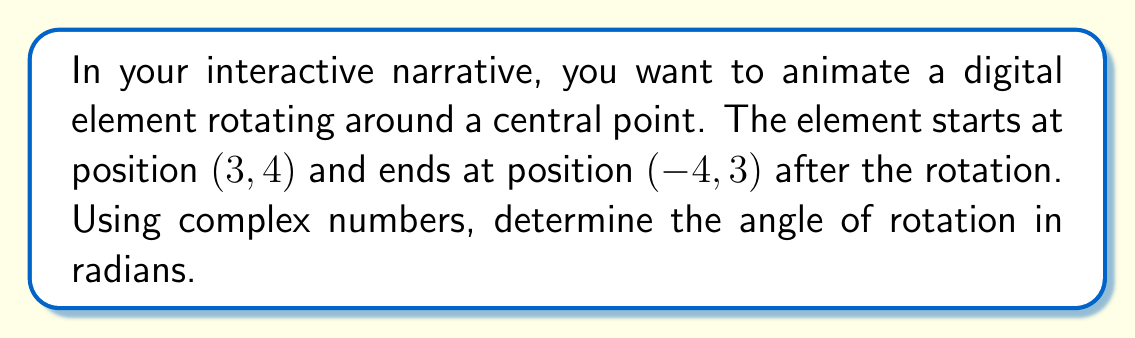Teach me how to tackle this problem. To solve this problem, we'll follow these steps:

1) Represent the initial and final positions as complex numbers:
   Initial: $z_1 = 3 + 4i$
   Final: $z_2 = -4 + 3i$

2) The rotation angle $\theta$ is the argument of the quotient $\frac{z_2}{z_1}$:

   $$\theta = \arg\left(\frac{z_2}{z_1}\right)$$

3) Calculate $\frac{z_2}{z_1}$:

   $$\frac{z_2}{z_1} = \frac{-4+3i}{3+4i} \cdot \frac{3-4i}{3-4i} = \frac{(-4+3i)(3-4i)}{(3+4i)(3-4i)}$$

   $$= \frac{-12+16i+9i-12i^2}{9+16} = \frac{0+13i}{25} = \frac{13i}{25}$$

4) The argument of a complex number $a+bi$ is given by $\arctan(\frac{b}{a})$. Here, we have $\frac{13i}{25}$, which is equivalent to $0 + \frac{13}{25}i$. Thus:

   $$\theta = \arctan\left(\frac{13/25}{0}\right) = \frac{\pi}{2}$$

5) However, we need to be careful here. The arctan function only gives values in the range $(-\frac{\pi}{2}, \frac{\pi}{2})$. Since our result is exactly $\frac{\pi}{2}$, we need to confirm if this is correct.

6) We can check by rotating $z_1$ by $\frac{\pi}{2}$:

   $$z_1 \cdot e^{i\frac{\pi}{2}} = (3+4i)(i) = 3i - 4 = -4 + 3i = z_2$$

   This confirms that $\frac{\pi}{2}$ is indeed the correct angle of rotation.
Answer: $\frac{\pi}{2}$ radians 